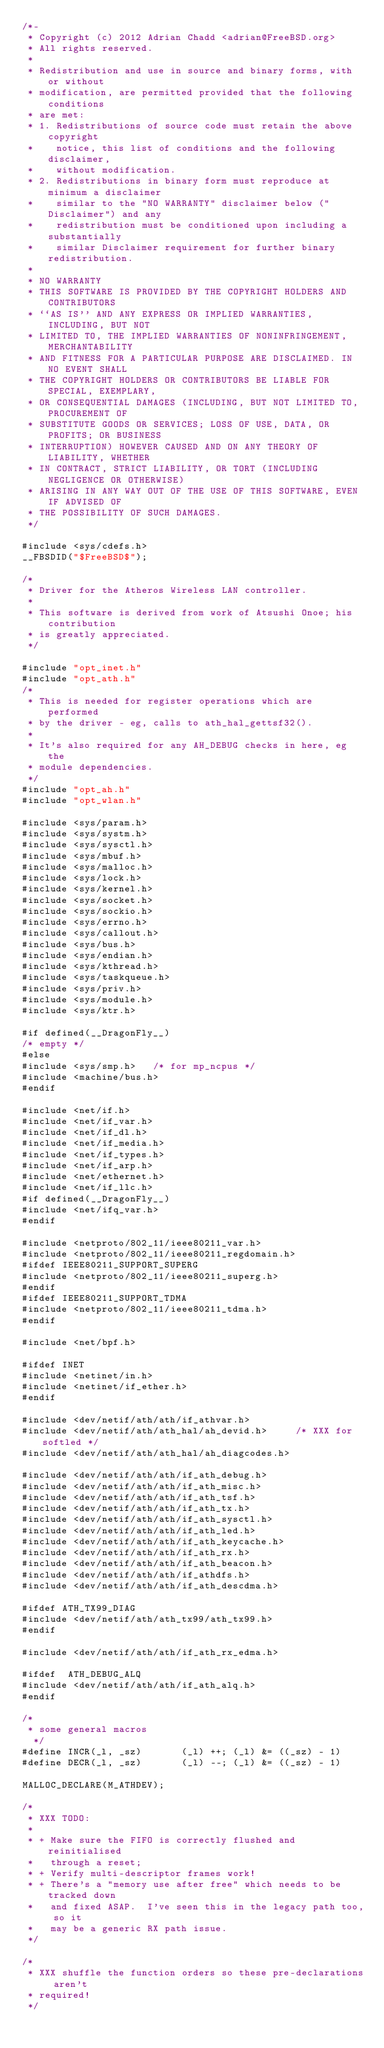<code> <loc_0><loc_0><loc_500><loc_500><_C_>/*-
 * Copyright (c) 2012 Adrian Chadd <adrian@FreeBSD.org>
 * All rights reserved.
 *
 * Redistribution and use in source and binary forms, with or without
 * modification, are permitted provided that the following conditions
 * are met:
 * 1. Redistributions of source code must retain the above copyright
 *    notice, this list of conditions and the following disclaimer,
 *    without modification.
 * 2. Redistributions in binary form must reproduce at minimum a disclaimer
 *    similar to the "NO WARRANTY" disclaimer below ("Disclaimer") and any
 *    redistribution must be conditioned upon including a substantially
 *    similar Disclaimer requirement for further binary redistribution.
 *
 * NO WARRANTY
 * THIS SOFTWARE IS PROVIDED BY THE COPYRIGHT HOLDERS AND CONTRIBUTORS
 * ``AS IS'' AND ANY EXPRESS OR IMPLIED WARRANTIES, INCLUDING, BUT NOT
 * LIMITED TO, THE IMPLIED WARRANTIES OF NONINFRINGEMENT, MERCHANTABILITY
 * AND FITNESS FOR A PARTICULAR PURPOSE ARE DISCLAIMED. IN NO EVENT SHALL
 * THE COPYRIGHT HOLDERS OR CONTRIBUTORS BE LIABLE FOR SPECIAL, EXEMPLARY,
 * OR CONSEQUENTIAL DAMAGES (INCLUDING, BUT NOT LIMITED TO, PROCUREMENT OF
 * SUBSTITUTE GOODS OR SERVICES; LOSS OF USE, DATA, OR PROFITS; OR BUSINESS
 * INTERRUPTION) HOWEVER CAUSED AND ON ANY THEORY OF LIABILITY, WHETHER
 * IN CONTRACT, STRICT LIABILITY, OR TORT (INCLUDING NEGLIGENCE OR OTHERWISE)
 * ARISING IN ANY WAY OUT OF THE USE OF THIS SOFTWARE, EVEN IF ADVISED OF
 * THE POSSIBILITY OF SUCH DAMAGES.
 */

#include <sys/cdefs.h>
__FBSDID("$FreeBSD$");

/*
 * Driver for the Atheros Wireless LAN controller.
 *
 * This software is derived from work of Atsushi Onoe; his contribution
 * is greatly appreciated.
 */

#include "opt_inet.h"
#include "opt_ath.h"
/*
 * This is needed for register operations which are performed
 * by the driver - eg, calls to ath_hal_gettsf32().
 *
 * It's also required for any AH_DEBUG checks in here, eg the
 * module dependencies.
 */
#include "opt_ah.h"
#include "opt_wlan.h"

#include <sys/param.h>
#include <sys/systm.h>
#include <sys/sysctl.h>
#include <sys/mbuf.h>
#include <sys/malloc.h>
#include <sys/lock.h>
#include <sys/kernel.h>
#include <sys/socket.h>
#include <sys/sockio.h>
#include <sys/errno.h>
#include <sys/callout.h>
#include <sys/bus.h>
#include <sys/endian.h>
#include <sys/kthread.h>
#include <sys/taskqueue.h>
#include <sys/priv.h>
#include <sys/module.h>
#include <sys/ktr.h>

#if defined(__DragonFly__)
/* empty */
#else
#include <sys/smp.h>   /* for mp_ncpus */
#include <machine/bus.h>
#endif

#include <net/if.h>
#include <net/if_var.h>
#include <net/if_dl.h>
#include <net/if_media.h>
#include <net/if_types.h>
#include <net/if_arp.h>
#include <net/ethernet.h>
#include <net/if_llc.h>
#if defined(__DragonFly__)
#include <net/ifq_var.h>
#endif

#include <netproto/802_11/ieee80211_var.h>
#include <netproto/802_11/ieee80211_regdomain.h>
#ifdef IEEE80211_SUPPORT_SUPERG
#include <netproto/802_11/ieee80211_superg.h>
#endif
#ifdef IEEE80211_SUPPORT_TDMA
#include <netproto/802_11/ieee80211_tdma.h>
#endif

#include <net/bpf.h>

#ifdef INET
#include <netinet/in.h>
#include <netinet/if_ether.h>
#endif

#include <dev/netif/ath/ath/if_athvar.h>
#include <dev/netif/ath/ath_hal/ah_devid.h>		/* XXX for softled */
#include <dev/netif/ath/ath_hal/ah_diagcodes.h>

#include <dev/netif/ath/ath/if_ath_debug.h>
#include <dev/netif/ath/ath/if_ath_misc.h>
#include <dev/netif/ath/ath/if_ath_tsf.h>
#include <dev/netif/ath/ath/if_ath_tx.h>
#include <dev/netif/ath/ath/if_ath_sysctl.h>
#include <dev/netif/ath/ath/if_ath_led.h>
#include <dev/netif/ath/ath/if_ath_keycache.h>
#include <dev/netif/ath/ath/if_ath_rx.h>
#include <dev/netif/ath/ath/if_ath_beacon.h>
#include <dev/netif/ath/ath/if_athdfs.h>
#include <dev/netif/ath/ath/if_ath_descdma.h>

#ifdef ATH_TX99_DIAG
#include <dev/netif/ath/ath_tx99/ath_tx99.h>
#endif

#include <dev/netif/ath/ath/if_ath_rx_edma.h>

#ifdef	ATH_DEBUG_ALQ
#include <dev/netif/ath/ath/if_ath_alq.h>
#endif

/*
 * some general macros
  */
#define	INCR(_l, _sz)		(_l) ++; (_l) &= ((_sz) - 1)
#define	DECR(_l, _sz)		(_l) --; (_l) &= ((_sz) - 1)

MALLOC_DECLARE(M_ATHDEV);

/*
 * XXX TODO:
 *
 * + Make sure the FIFO is correctly flushed and reinitialised
 *   through a reset;
 * + Verify multi-descriptor frames work!
 * + There's a "memory use after free" which needs to be tracked down
 *   and fixed ASAP.  I've seen this in the legacy path too, so it
 *   may be a generic RX path issue.
 */

/*
 * XXX shuffle the function orders so these pre-declarations aren't
 * required!
 */</code> 